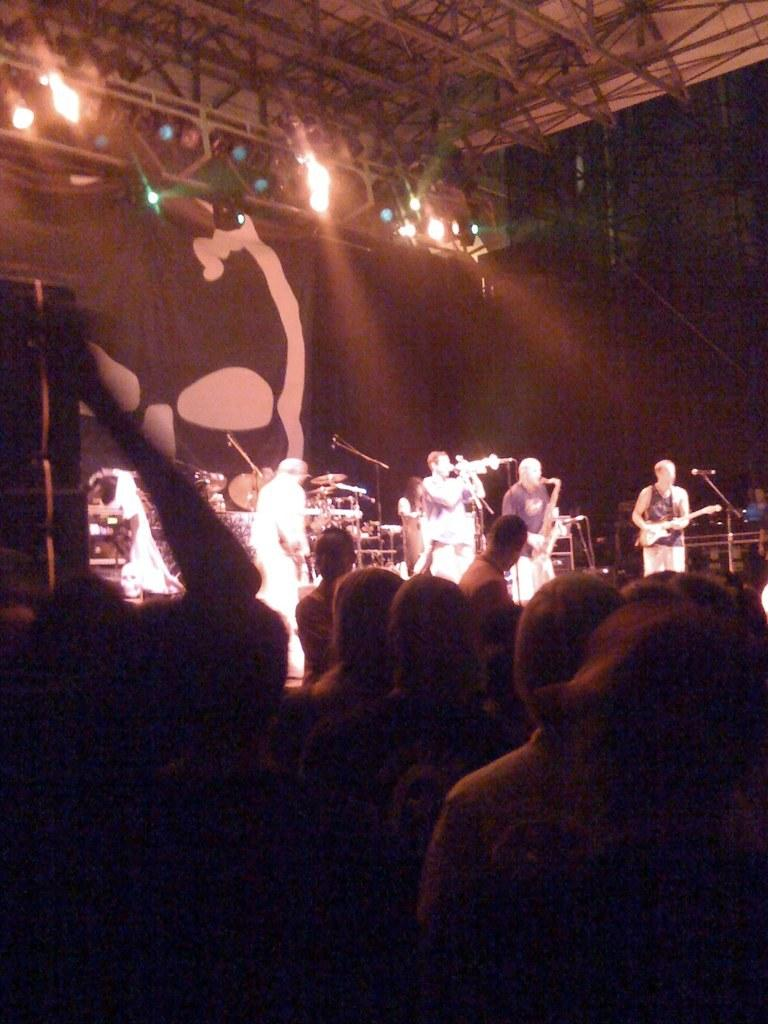What is happening on the stage in the image? There are people on the stage in the image. Can you describe the people in the foreground of the image? There are people in the foreground of the image. What can be seen in the background of the image? There is a banner and lights visible in the background of the image. How many pizzas are being served on stage in the image? There is no mention of pizzas in the image; it features people on stage. Can you see steam coming from the lights in the background of the image? There is no mention of steam in the image; it only mentions lights in the background. 